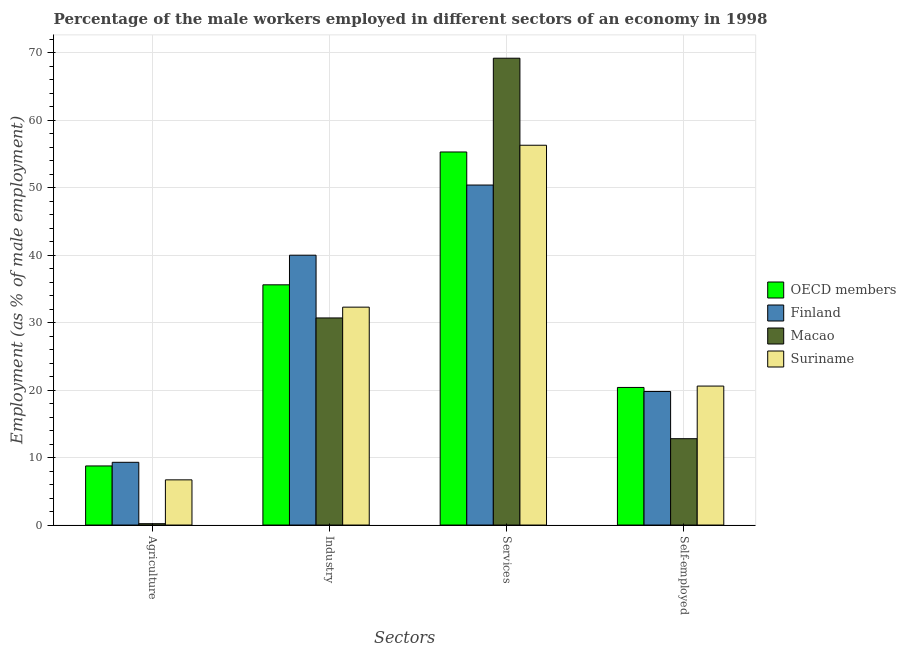How many different coloured bars are there?
Your response must be concise. 4. Are the number of bars on each tick of the X-axis equal?
Your answer should be very brief. Yes. What is the label of the 2nd group of bars from the left?
Your response must be concise. Industry. What is the percentage of self employed male workers in Macao?
Make the answer very short. 12.8. Across all countries, what is the maximum percentage of male workers in agriculture?
Ensure brevity in your answer.  9.3. Across all countries, what is the minimum percentage of male workers in agriculture?
Your answer should be very brief. 0.2. In which country was the percentage of male workers in agriculture maximum?
Make the answer very short. Finland. In which country was the percentage of male workers in industry minimum?
Your answer should be compact. Macao. What is the total percentage of male workers in agriculture in the graph?
Ensure brevity in your answer.  24.96. What is the difference between the percentage of male workers in agriculture in OECD members and that in Finland?
Provide a short and direct response. -0.54. What is the difference between the percentage of male workers in industry in Finland and the percentage of male workers in agriculture in Suriname?
Your answer should be compact. 33.3. What is the average percentage of self employed male workers per country?
Offer a very short reply. 18.4. What is the difference between the percentage of male workers in services and percentage of self employed male workers in OECD members?
Your answer should be compact. 34.9. What is the ratio of the percentage of self employed male workers in OECD members to that in Suriname?
Your response must be concise. 0.99. Is the percentage of male workers in industry in Suriname less than that in Macao?
Offer a terse response. No. Is the difference between the percentage of self employed male workers in OECD members and Suriname greater than the difference between the percentage of male workers in services in OECD members and Suriname?
Your response must be concise. Yes. What is the difference between the highest and the second highest percentage of male workers in industry?
Your answer should be very brief. 4.39. What is the difference between the highest and the lowest percentage of male workers in industry?
Give a very brief answer. 9.3. In how many countries, is the percentage of male workers in services greater than the average percentage of male workers in services taken over all countries?
Provide a short and direct response. 1. Is the sum of the percentage of male workers in agriculture in Suriname and OECD members greater than the maximum percentage of male workers in industry across all countries?
Offer a very short reply. No. What does the 3rd bar from the left in Self-employed represents?
Your answer should be compact. Macao. What does the 4th bar from the right in Self-employed represents?
Offer a terse response. OECD members. Is it the case that in every country, the sum of the percentage of male workers in agriculture and percentage of male workers in industry is greater than the percentage of male workers in services?
Provide a succinct answer. No. How many bars are there?
Your answer should be compact. 16. What is the difference between two consecutive major ticks on the Y-axis?
Ensure brevity in your answer.  10. Are the values on the major ticks of Y-axis written in scientific E-notation?
Provide a short and direct response. No. What is the title of the graph?
Keep it short and to the point. Percentage of the male workers employed in different sectors of an economy in 1998. What is the label or title of the X-axis?
Keep it short and to the point. Sectors. What is the label or title of the Y-axis?
Give a very brief answer. Employment (as % of male employment). What is the Employment (as % of male employment) of OECD members in Agriculture?
Your answer should be compact. 8.76. What is the Employment (as % of male employment) in Finland in Agriculture?
Your answer should be very brief. 9.3. What is the Employment (as % of male employment) in Macao in Agriculture?
Provide a succinct answer. 0.2. What is the Employment (as % of male employment) in Suriname in Agriculture?
Keep it short and to the point. 6.7. What is the Employment (as % of male employment) in OECD members in Industry?
Give a very brief answer. 35.61. What is the Employment (as % of male employment) of Macao in Industry?
Ensure brevity in your answer.  30.7. What is the Employment (as % of male employment) of Suriname in Industry?
Provide a succinct answer. 32.3. What is the Employment (as % of male employment) in OECD members in Services?
Keep it short and to the point. 55.3. What is the Employment (as % of male employment) in Finland in Services?
Your answer should be very brief. 50.4. What is the Employment (as % of male employment) in Macao in Services?
Provide a succinct answer. 69.2. What is the Employment (as % of male employment) in Suriname in Services?
Your answer should be very brief. 56.3. What is the Employment (as % of male employment) of OECD members in Self-employed?
Keep it short and to the point. 20.4. What is the Employment (as % of male employment) in Finland in Self-employed?
Keep it short and to the point. 19.8. What is the Employment (as % of male employment) of Macao in Self-employed?
Provide a short and direct response. 12.8. What is the Employment (as % of male employment) in Suriname in Self-employed?
Your answer should be compact. 20.6. Across all Sectors, what is the maximum Employment (as % of male employment) of OECD members?
Your response must be concise. 55.3. Across all Sectors, what is the maximum Employment (as % of male employment) of Finland?
Your response must be concise. 50.4. Across all Sectors, what is the maximum Employment (as % of male employment) of Macao?
Give a very brief answer. 69.2. Across all Sectors, what is the maximum Employment (as % of male employment) in Suriname?
Your answer should be very brief. 56.3. Across all Sectors, what is the minimum Employment (as % of male employment) of OECD members?
Provide a short and direct response. 8.76. Across all Sectors, what is the minimum Employment (as % of male employment) of Finland?
Your response must be concise. 9.3. Across all Sectors, what is the minimum Employment (as % of male employment) of Macao?
Your response must be concise. 0.2. Across all Sectors, what is the minimum Employment (as % of male employment) in Suriname?
Keep it short and to the point. 6.7. What is the total Employment (as % of male employment) of OECD members in the graph?
Your answer should be very brief. 120.07. What is the total Employment (as % of male employment) of Finland in the graph?
Your answer should be compact. 119.5. What is the total Employment (as % of male employment) in Macao in the graph?
Give a very brief answer. 112.9. What is the total Employment (as % of male employment) of Suriname in the graph?
Provide a short and direct response. 115.9. What is the difference between the Employment (as % of male employment) in OECD members in Agriculture and that in Industry?
Give a very brief answer. -26.85. What is the difference between the Employment (as % of male employment) of Finland in Agriculture and that in Industry?
Provide a succinct answer. -30.7. What is the difference between the Employment (as % of male employment) of Macao in Agriculture and that in Industry?
Give a very brief answer. -30.5. What is the difference between the Employment (as % of male employment) in Suriname in Agriculture and that in Industry?
Your answer should be compact. -25.6. What is the difference between the Employment (as % of male employment) of OECD members in Agriculture and that in Services?
Provide a short and direct response. -46.54. What is the difference between the Employment (as % of male employment) in Finland in Agriculture and that in Services?
Ensure brevity in your answer.  -41.1. What is the difference between the Employment (as % of male employment) of Macao in Agriculture and that in Services?
Provide a short and direct response. -69. What is the difference between the Employment (as % of male employment) in Suriname in Agriculture and that in Services?
Provide a short and direct response. -49.6. What is the difference between the Employment (as % of male employment) of OECD members in Agriculture and that in Self-employed?
Provide a succinct answer. -11.64. What is the difference between the Employment (as % of male employment) of Finland in Agriculture and that in Self-employed?
Offer a very short reply. -10.5. What is the difference between the Employment (as % of male employment) of OECD members in Industry and that in Services?
Make the answer very short. -19.69. What is the difference between the Employment (as % of male employment) in Finland in Industry and that in Services?
Provide a succinct answer. -10.4. What is the difference between the Employment (as % of male employment) of Macao in Industry and that in Services?
Ensure brevity in your answer.  -38.5. What is the difference between the Employment (as % of male employment) in OECD members in Industry and that in Self-employed?
Offer a terse response. 15.21. What is the difference between the Employment (as % of male employment) in Finland in Industry and that in Self-employed?
Give a very brief answer. 20.2. What is the difference between the Employment (as % of male employment) of Suriname in Industry and that in Self-employed?
Ensure brevity in your answer.  11.7. What is the difference between the Employment (as % of male employment) of OECD members in Services and that in Self-employed?
Your answer should be very brief. 34.91. What is the difference between the Employment (as % of male employment) of Finland in Services and that in Self-employed?
Give a very brief answer. 30.6. What is the difference between the Employment (as % of male employment) of Macao in Services and that in Self-employed?
Provide a short and direct response. 56.4. What is the difference between the Employment (as % of male employment) of Suriname in Services and that in Self-employed?
Make the answer very short. 35.7. What is the difference between the Employment (as % of male employment) of OECD members in Agriculture and the Employment (as % of male employment) of Finland in Industry?
Offer a terse response. -31.24. What is the difference between the Employment (as % of male employment) of OECD members in Agriculture and the Employment (as % of male employment) of Macao in Industry?
Provide a short and direct response. -21.94. What is the difference between the Employment (as % of male employment) in OECD members in Agriculture and the Employment (as % of male employment) in Suriname in Industry?
Give a very brief answer. -23.54. What is the difference between the Employment (as % of male employment) in Finland in Agriculture and the Employment (as % of male employment) in Macao in Industry?
Your response must be concise. -21.4. What is the difference between the Employment (as % of male employment) in Finland in Agriculture and the Employment (as % of male employment) in Suriname in Industry?
Offer a terse response. -23. What is the difference between the Employment (as % of male employment) of Macao in Agriculture and the Employment (as % of male employment) of Suriname in Industry?
Keep it short and to the point. -32.1. What is the difference between the Employment (as % of male employment) in OECD members in Agriculture and the Employment (as % of male employment) in Finland in Services?
Your answer should be very brief. -41.64. What is the difference between the Employment (as % of male employment) in OECD members in Agriculture and the Employment (as % of male employment) in Macao in Services?
Give a very brief answer. -60.44. What is the difference between the Employment (as % of male employment) in OECD members in Agriculture and the Employment (as % of male employment) in Suriname in Services?
Offer a very short reply. -47.54. What is the difference between the Employment (as % of male employment) of Finland in Agriculture and the Employment (as % of male employment) of Macao in Services?
Make the answer very short. -59.9. What is the difference between the Employment (as % of male employment) of Finland in Agriculture and the Employment (as % of male employment) of Suriname in Services?
Provide a succinct answer. -47. What is the difference between the Employment (as % of male employment) of Macao in Agriculture and the Employment (as % of male employment) of Suriname in Services?
Give a very brief answer. -56.1. What is the difference between the Employment (as % of male employment) of OECD members in Agriculture and the Employment (as % of male employment) of Finland in Self-employed?
Your response must be concise. -11.04. What is the difference between the Employment (as % of male employment) of OECD members in Agriculture and the Employment (as % of male employment) of Macao in Self-employed?
Provide a succinct answer. -4.04. What is the difference between the Employment (as % of male employment) of OECD members in Agriculture and the Employment (as % of male employment) of Suriname in Self-employed?
Give a very brief answer. -11.84. What is the difference between the Employment (as % of male employment) in Finland in Agriculture and the Employment (as % of male employment) in Suriname in Self-employed?
Provide a succinct answer. -11.3. What is the difference between the Employment (as % of male employment) in Macao in Agriculture and the Employment (as % of male employment) in Suriname in Self-employed?
Provide a succinct answer. -20.4. What is the difference between the Employment (as % of male employment) of OECD members in Industry and the Employment (as % of male employment) of Finland in Services?
Make the answer very short. -14.79. What is the difference between the Employment (as % of male employment) in OECD members in Industry and the Employment (as % of male employment) in Macao in Services?
Keep it short and to the point. -33.59. What is the difference between the Employment (as % of male employment) of OECD members in Industry and the Employment (as % of male employment) of Suriname in Services?
Offer a terse response. -20.69. What is the difference between the Employment (as % of male employment) of Finland in Industry and the Employment (as % of male employment) of Macao in Services?
Make the answer very short. -29.2. What is the difference between the Employment (as % of male employment) of Finland in Industry and the Employment (as % of male employment) of Suriname in Services?
Offer a terse response. -16.3. What is the difference between the Employment (as % of male employment) in Macao in Industry and the Employment (as % of male employment) in Suriname in Services?
Give a very brief answer. -25.6. What is the difference between the Employment (as % of male employment) of OECD members in Industry and the Employment (as % of male employment) of Finland in Self-employed?
Make the answer very short. 15.81. What is the difference between the Employment (as % of male employment) in OECD members in Industry and the Employment (as % of male employment) in Macao in Self-employed?
Your response must be concise. 22.81. What is the difference between the Employment (as % of male employment) of OECD members in Industry and the Employment (as % of male employment) of Suriname in Self-employed?
Offer a terse response. 15.01. What is the difference between the Employment (as % of male employment) in Finland in Industry and the Employment (as % of male employment) in Macao in Self-employed?
Your answer should be compact. 27.2. What is the difference between the Employment (as % of male employment) in Finland in Industry and the Employment (as % of male employment) in Suriname in Self-employed?
Make the answer very short. 19.4. What is the difference between the Employment (as % of male employment) in Macao in Industry and the Employment (as % of male employment) in Suriname in Self-employed?
Your response must be concise. 10.1. What is the difference between the Employment (as % of male employment) in OECD members in Services and the Employment (as % of male employment) in Finland in Self-employed?
Make the answer very short. 35.5. What is the difference between the Employment (as % of male employment) of OECD members in Services and the Employment (as % of male employment) of Macao in Self-employed?
Keep it short and to the point. 42.5. What is the difference between the Employment (as % of male employment) in OECD members in Services and the Employment (as % of male employment) in Suriname in Self-employed?
Your answer should be compact. 34.7. What is the difference between the Employment (as % of male employment) in Finland in Services and the Employment (as % of male employment) in Macao in Self-employed?
Provide a short and direct response. 37.6. What is the difference between the Employment (as % of male employment) in Finland in Services and the Employment (as % of male employment) in Suriname in Self-employed?
Ensure brevity in your answer.  29.8. What is the difference between the Employment (as % of male employment) in Macao in Services and the Employment (as % of male employment) in Suriname in Self-employed?
Provide a succinct answer. 48.6. What is the average Employment (as % of male employment) in OECD members per Sectors?
Ensure brevity in your answer.  30.02. What is the average Employment (as % of male employment) in Finland per Sectors?
Offer a terse response. 29.88. What is the average Employment (as % of male employment) of Macao per Sectors?
Offer a terse response. 28.23. What is the average Employment (as % of male employment) in Suriname per Sectors?
Ensure brevity in your answer.  28.98. What is the difference between the Employment (as % of male employment) of OECD members and Employment (as % of male employment) of Finland in Agriculture?
Keep it short and to the point. -0.54. What is the difference between the Employment (as % of male employment) in OECD members and Employment (as % of male employment) in Macao in Agriculture?
Your answer should be very brief. 8.56. What is the difference between the Employment (as % of male employment) in OECD members and Employment (as % of male employment) in Suriname in Agriculture?
Your response must be concise. 2.06. What is the difference between the Employment (as % of male employment) in Finland and Employment (as % of male employment) in Macao in Agriculture?
Ensure brevity in your answer.  9.1. What is the difference between the Employment (as % of male employment) of Macao and Employment (as % of male employment) of Suriname in Agriculture?
Your response must be concise. -6.5. What is the difference between the Employment (as % of male employment) in OECD members and Employment (as % of male employment) in Finland in Industry?
Keep it short and to the point. -4.39. What is the difference between the Employment (as % of male employment) of OECD members and Employment (as % of male employment) of Macao in Industry?
Ensure brevity in your answer.  4.91. What is the difference between the Employment (as % of male employment) in OECD members and Employment (as % of male employment) in Suriname in Industry?
Your answer should be compact. 3.31. What is the difference between the Employment (as % of male employment) of Macao and Employment (as % of male employment) of Suriname in Industry?
Keep it short and to the point. -1.6. What is the difference between the Employment (as % of male employment) of OECD members and Employment (as % of male employment) of Finland in Services?
Provide a succinct answer. 4.9. What is the difference between the Employment (as % of male employment) in OECD members and Employment (as % of male employment) in Macao in Services?
Give a very brief answer. -13.9. What is the difference between the Employment (as % of male employment) in OECD members and Employment (as % of male employment) in Suriname in Services?
Offer a very short reply. -1. What is the difference between the Employment (as % of male employment) of Finland and Employment (as % of male employment) of Macao in Services?
Offer a very short reply. -18.8. What is the difference between the Employment (as % of male employment) in OECD members and Employment (as % of male employment) in Finland in Self-employed?
Make the answer very short. 0.6. What is the difference between the Employment (as % of male employment) of OECD members and Employment (as % of male employment) of Macao in Self-employed?
Your answer should be compact. 7.6. What is the difference between the Employment (as % of male employment) in OECD members and Employment (as % of male employment) in Suriname in Self-employed?
Keep it short and to the point. -0.2. What is the difference between the Employment (as % of male employment) of Finland and Employment (as % of male employment) of Suriname in Self-employed?
Offer a terse response. -0.8. What is the ratio of the Employment (as % of male employment) in OECD members in Agriculture to that in Industry?
Offer a very short reply. 0.25. What is the ratio of the Employment (as % of male employment) in Finland in Agriculture to that in Industry?
Make the answer very short. 0.23. What is the ratio of the Employment (as % of male employment) of Macao in Agriculture to that in Industry?
Make the answer very short. 0.01. What is the ratio of the Employment (as % of male employment) in Suriname in Agriculture to that in Industry?
Provide a short and direct response. 0.21. What is the ratio of the Employment (as % of male employment) of OECD members in Agriculture to that in Services?
Provide a succinct answer. 0.16. What is the ratio of the Employment (as % of male employment) of Finland in Agriculture to that in Services?
Provide a short and direct response. 0.18. What is the ratio of the Employment (as % of male employment) of Macao in Agriculture to that in Services?
Keep it short and to the point. 0. What is the ratio of the Employment (as % of male employment) of Suriname in Agriculture to that in Services?
Provide a succinct answer. 0.12. What is the ratio of the Employment (as % of male employment) of OECD members in Agriculture to that in Self-employed?
Provide a short and direct response. 0.43. What is the ratio of the Employment (as % of male employment) of Finland in Agriculture to that in Self-employed?
Provide a succinct answer. 0.47. What is the ratio of the Employment (as % of male employment) of Macao in Agriculture to that in Self-employed?
Keep it short and to the point. 0.02. What is the ratio of the Employment (as % of male employment) of Suriname in Agriculture to that in Self-employed?
Provide a succinct answer. 0.33. What is the ratio of the Employment (as % of male employment) of OECD members in Industry to that in Services?
Give a very brief answer. 0.64. What is the ratio of the Employment (as % of male employment) in Finland in Industry to that in Services?
Give a very brief answer. 0.79. What is the ratio of the Employment (as % of male employment) of Macao in Industry to that in Services?
Keep it short and to the point. 0.44. What is the ratio of the Employment (as % of male employment) in Suriname in Industry to that in Services?
Provide a short and direct response. 0.57. What is the ratio of the Employment (as % of male employment) of OECD members in Industry to that in Self-employed?
Keep it short and to the point. 1.75. What is the ratio of the Employment (as % of male employment) of Finland in Industry to that in Self-employed?
Offer a terse response. 2.02. What is the ratio of the Employment (as % of male employment) of Macao in Industry to that in Self-employed?
Keep it short and to the point. 2.4. What is the ratio of the Employment (as % of male employment) of Suriname in Industry to that in Self-employed?
Your answer should be compact. 1.57. What is the ratio of the Employment (as % of male employment) of OECD members in Services to that in Self-employed?
Offer a terse response. 2.71. What is the ratio of the Employment (as % of male employment) in Finland in Services to that in Self-employed?
Make the answer very short. 2.55. What is the ratio of the Employment (as % of male employment) in Macao in Services to that in Self-employed?
Your response must be concise. 5.41. What is the ratio of the Employment (as % of male employment) in Suriname in Services to that in Self-employed?
Provide a short and direct response. 2.73. What is the difference between the highest and the second highest Employment (as % of male employment) of OECD members?
Ensure brevity in your answer.  19.69. What is the difference between the highest and the second highest Employment (as % of male employment) of Finland?
Provide a succinct answer. 10.4. What is the difference between the highest and the second highest Employment (as % of male employment) in Macao?
Provide a succinct answer. 38.5. What is the difference between the highest and the lowest Employment (as % of male employment) in OECD members?
Provide a short and direct response. 46.54. What is the difference between the highest and the lowest Employment (as % of male employment) in Finland?
Keep it short and to the point. 41.1. What is the difference between the highest and the lowest Employment (as % of male employment) in Macao?
Give a very brief answer. 69. What is the difference between the highest and the lowest Employment (as % of male employment) of Suriname?
Keep it short and to the point. 49.6. 